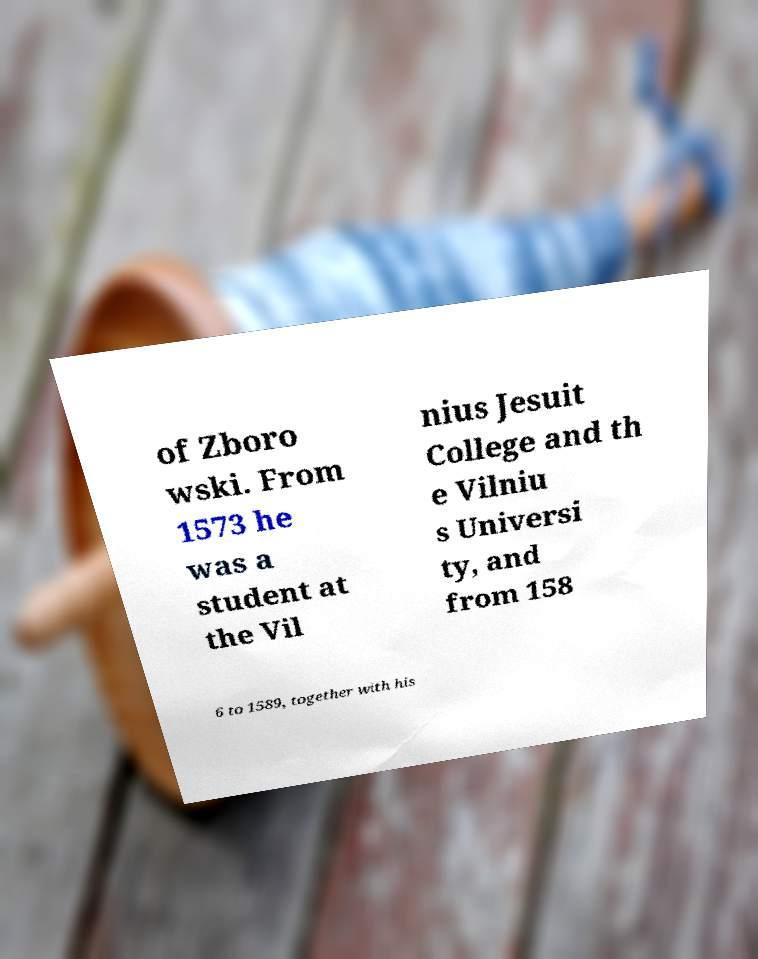Could you assist in decoding the text presented in this image and type it out clearly? of Zboro wski. From 1573 he was a student at the Vil nius Jesuit College and th e Vilniu s Universi ty, and from 158 6 to 1589, together with his 